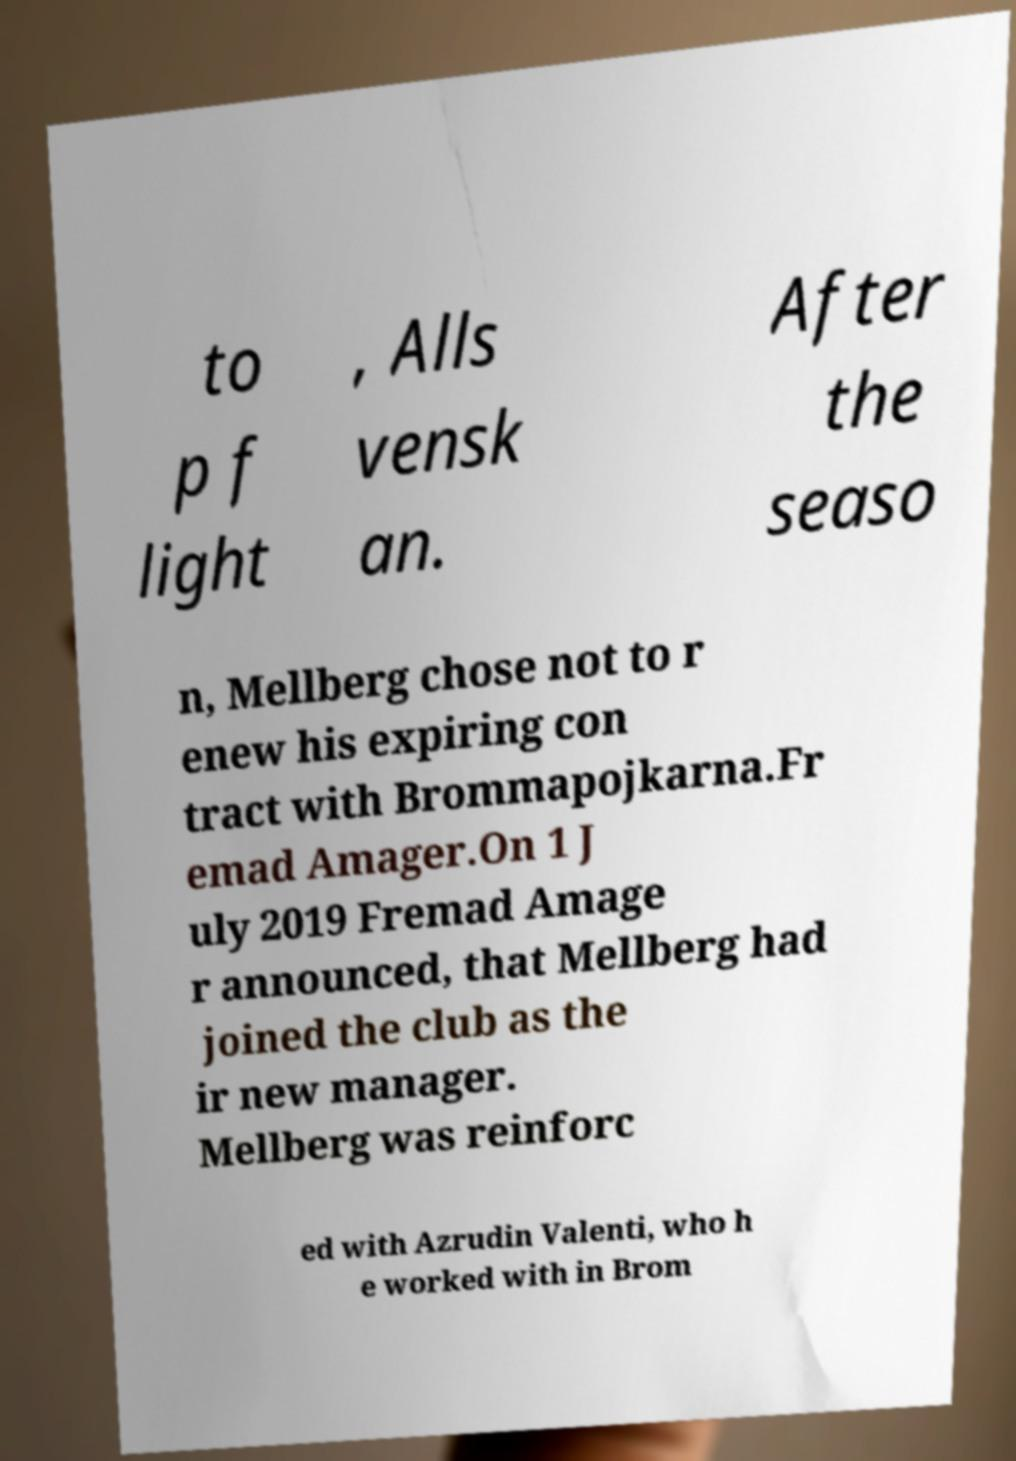Can you accurately transcribe the text from the provided image for me? to p f light , Alls vensk an. After the seaso n, Mellberg chose not to r enew his expiring con tract with Brommapojkarna.Fr emad Amager.On 1 J uly 2019 Fremad Amage r announced, that Mellberg had joined the club as the ir new manager. Mellberg was reinforc ed with Azrudin Valenti, who h e worked with in Brom 